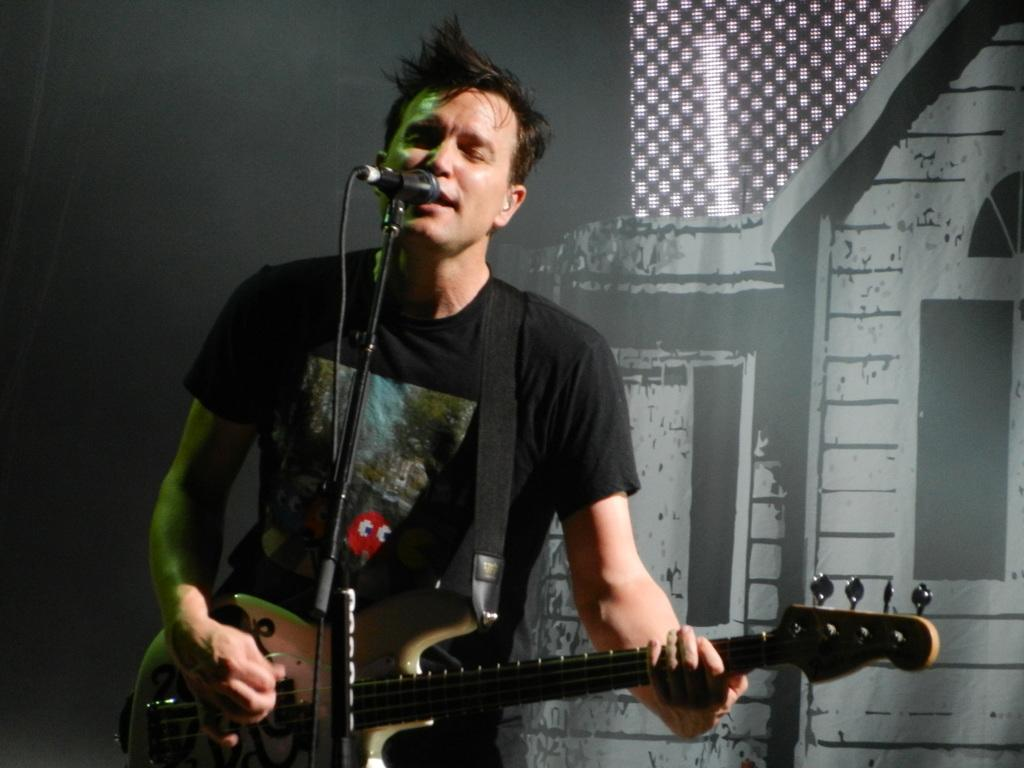What is the main subject of the image? There is a person standing in the center of the image. What is the person doing in the image? The person is playing a guitar. What object is in front of the person? There is a microphone in front of the person. What can be seen in the background of the image? There is a curtain in the background of the image. How many wilderness areas are visible in the image? There are no wilderness areas visible in the image; it features a person playing a guitar with a microphone and a curtain in the background. What type of fold can be seen on the shelf in the image? There is no shelf present in the image, so it is not possible to determine if there is a fold or any other object on it. 